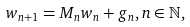<formula> <loc_0><loc_0><loc_500><loc_500>w _ { n + 1 } = M _ { n } w _ { n } + g _ { n } , n \in \mathbb { N } ,</formula> 